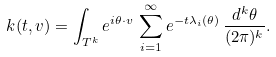Convert formula to latex. <formula><loc_0><loc_0><loc_500><loc_500>k ( t , v ) = \int _ { T ^ { k } } e ^ { i \theta \cdot v } \, \sum _ { i = 1 } ^ { \infty } e ^ { - t \lambda _ { i } ( \theta ) } \, \frac { d ^ { k } \theta } { ( 2 \pi ) ^ { k } } .</formula> 